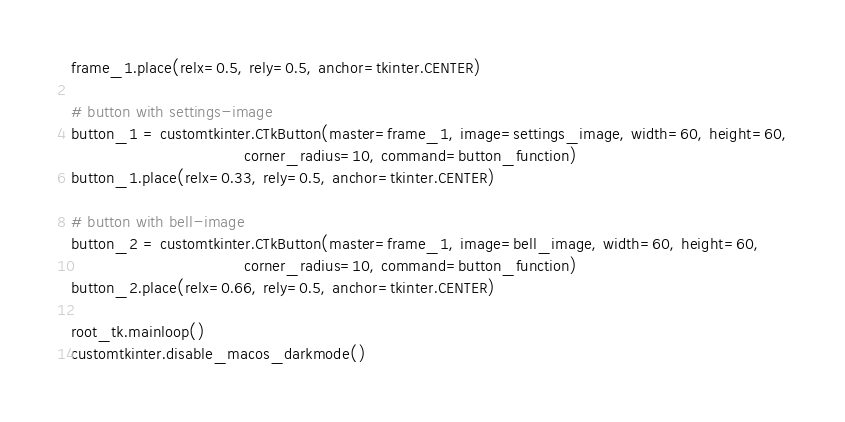Convert code to text. <code><loc_0><loc_0><loc_500><loc_500><_Python_>frame_1.place(relx=0.5, rely=0.5, anchor=tkinter.CENTER)

# button with settings-image
button_1 = customtkinter.CTkButton(master=frame_1, image=settings_image, width=60, height=60,
                                   corner_radius=10, command=button_function)
button_1.place(relx=0.33, rely=0.5, anchor=tkinter.CENTER)

# button with bell-image
button_2 = customtkinter.CTkButton(master=frame_1, image=bell_image, width=60, height=60,
                                   corner_radius=10, command=button_function)
button_2.place(relx=0.66, rely=0.5, anchor=tkinter.CENTER)

root_tk.mainloop()
customtkinter.disable_macos_darkmode()
</code> 